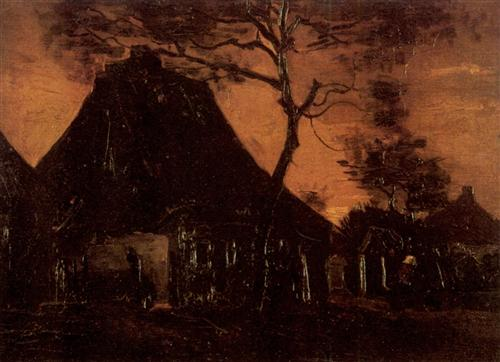What do you think is going on in this snapshot? The image depicts a detailed oil painting of a rural and desolate landscape. The focal point is a large thatched-roof cottage that seems to have been abandoned. A barren, twisted tree stands imposingly in front of the cottage, enhancing the feeling of desolation. The dark orange sky adds to the somber and eerie atmosphere of the scene. This painting, reflecting the style of the Dutch Golden Age, captures the essence of decay and abandonment. The use of dark tones and intricate detailing evokes a powerful and haunting image that conveys a story of solitude and perhaps a forgotten past. 